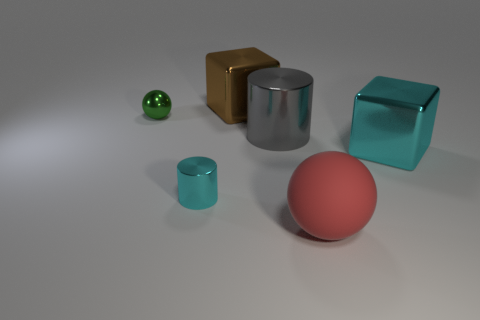Subtract 1 spheres. How many spheres are left? 1 Add 2 large blue blocks. How many objects exist? 8 Subtract all cyan cylinders. How many cylinders are left? 1 Subtract all cylinders. How many objects are left? 4 Subtract all gray spheres. How many gray cylinders are left? 1 Subtract all cyan blocks. Subtract all small cyan metallic cylinders. How many objects are left? 4 Add 4 large shiny blocks. How many large shiny blocks are left? 6 Add 4 big red matte spheres. How many big red matte spheres exist? 5 Subtract 0 cyan spheres. How many objects are left? 6 Subtract all yellow cylinders. Subtract all yellow blocks. How many cylinders are left? 2 